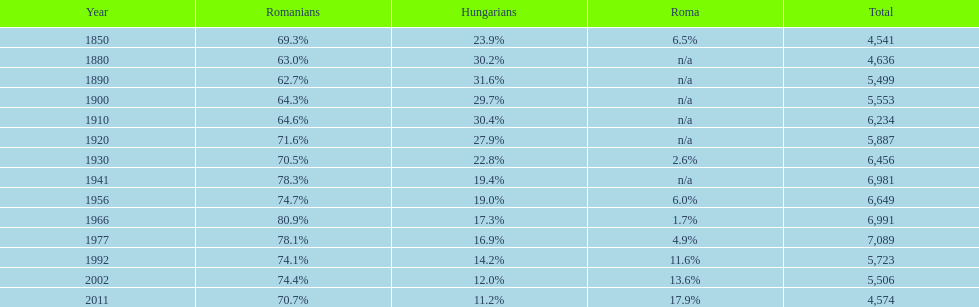What were the total number of times the romanians had a population percentage above 70%? 9. 